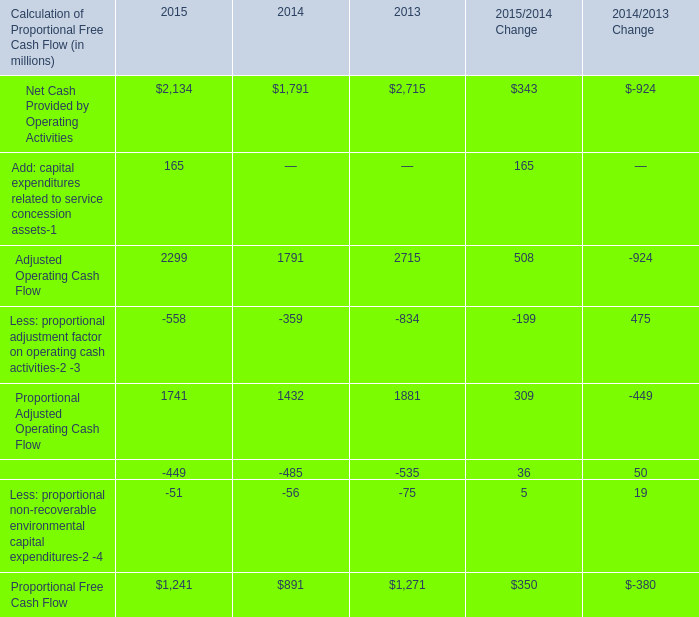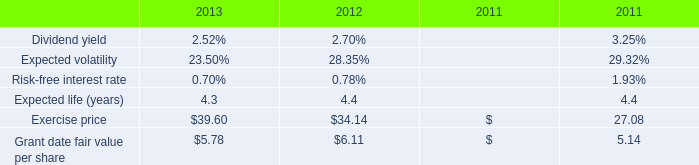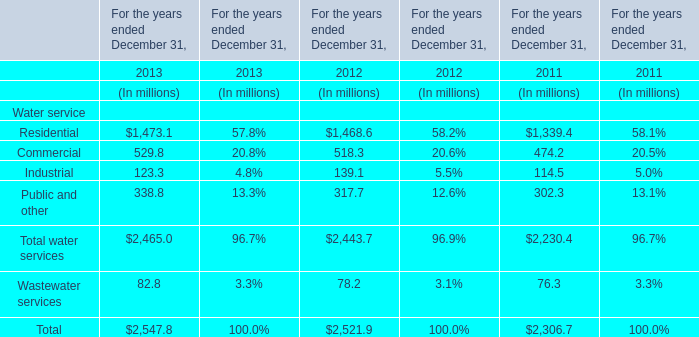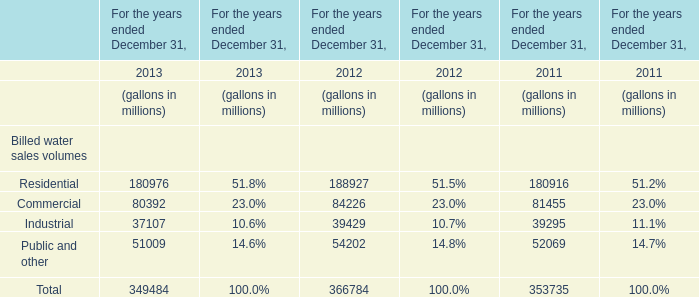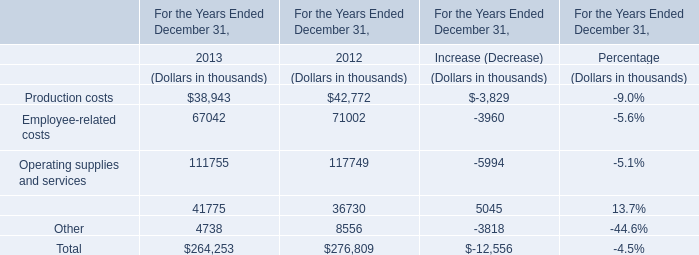What's the total amount of the Total water services in the year where Wastewater services is greater than 78.4? (in dollars in millions) 
Answer: 2465. 